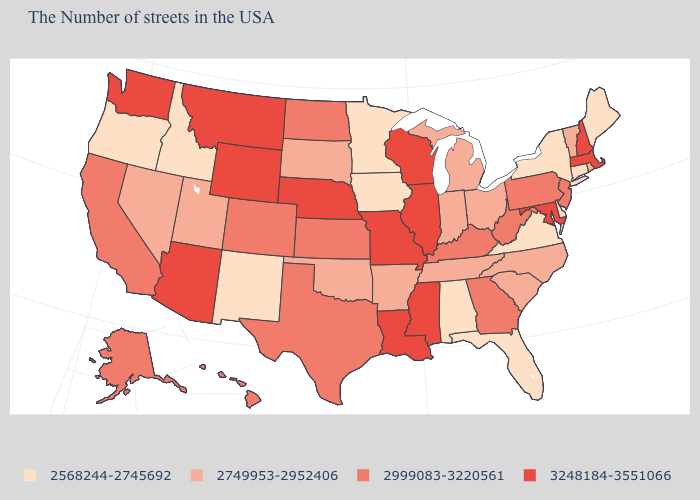Name the states that have a value in the range 2749953-2952406?
Give a very brief answer. Rhode Island, Vermont, North Carolina, South Carolina, Ohio, Michigan, Indiana, Tennessee, Arkansas, Oklahoma, South Dakota, Utah, Nevada. Name the states that have a value in the range 2568244-2745692?
Keep it brief. Maine, Connecticut, New York, Delaware, Virginia, Florida, Alabama, Minnesota, Iowa, New Mexico, Idaho, Oregon. What is the value of Virginia?
Be succinct. 2568244-2745692. Which states hav the highest value in the West?
Write a very short answer. Wyoming, Montana, Arizona, Washington. What is the value of Iowa?
Write a very short answer. 2568244-2745692. Which states have the highest value in the USA?
Keep it brief. Massachusetts, New Hampshire, Maryland, Wisconsin, Illinois, Mississippi, Louisiana, Missouri, Nebraska, Wyoming, Montana, Arizona, Washington. What is the value of Wyoming?
Write a very short answer. 3248184-3551066. What is the value of Washington?
Keep it brief. 3248184-3551066. What is the value of Tennessee?
Keep it brief. 2749953-2952406. Among the states that border Kansas , which have the highest value?
Short answer required. Missouri, Nebraska. Name the states that have a value in the range 2568244-2745692?
Be succinct. Maine, Connecticut, New York, Delaware, Virginia, Florida, Alabama, Minnesota, Iowa, New Mexico, Idaho, Oregon. Name the states that have a value in the range 3248184-3551066?
Concise answer only. Massachusetts, New Hampshire, Maryland, Wisconsin, Illinois, Mississippi, Louisiana, Missouri, Nebraska, Wyoming, Montana, Arizona, Washington. Does Louisiana have the highest value in the South?
Short answer required. Yes. Does Maine have the same value as Virginia?
Answer briefly. Yes. 